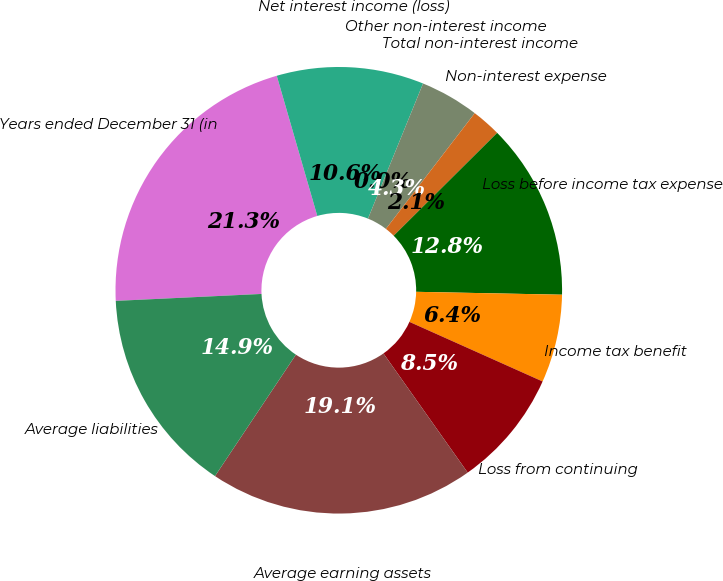<chart> <loc_0><loc_0><loc_500><loc_500><pie_chart><fcel>Years ended December 31 (in<fcel>Net interest income (loss)<fcel>Other non-interest income<fcel>Total non-interest income<fcel>Non-interest expense<fcel>Loss before income tax expense<fcel>Income tax benefit<fcel>Loss from continuing<fcel>Average earning assets<fcel>Average liabilities<nl><fcel>21.28%<fcel>10.64%<fcel>0.0%<fcel>4.26%<fcel>2.13%<fcel>12.77%<fcel>6.38%<fcel>8.51%<fcel>19.15%<fcel>14.89%<nl></chart> 